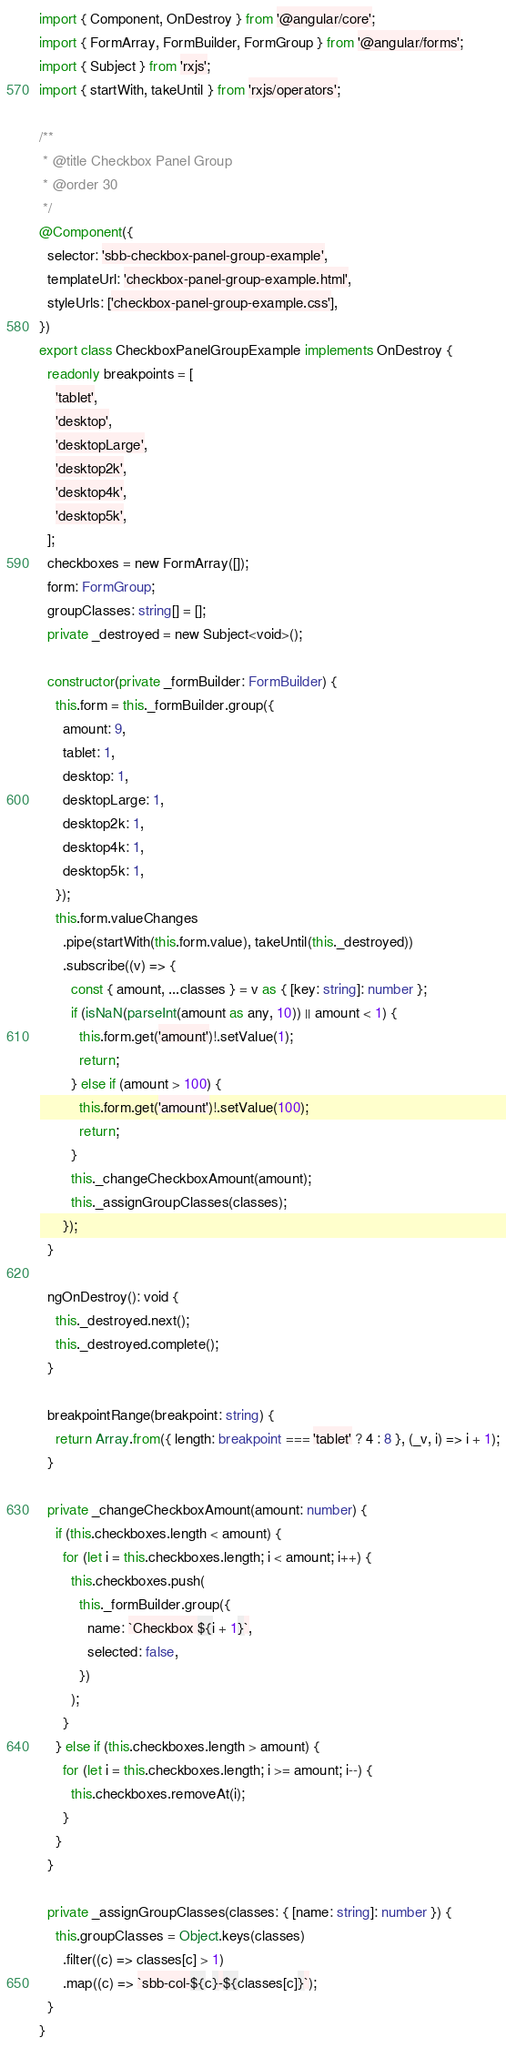<code> <loc_0><loc_0><loc_500><loc_500><_TypeScript_>import { Component, OnDestroy } from '@angular/core';
import { FormArray, FormBuilder, FormGroup } from '@angular/forms';
import { Subject } from 'rxjs';
import { startWith, takeUntil } from 'rxjs/operators';

/**
 * @title Checkbox Panel Group
 * @order 30
 */
@Component({
  selector: 'sbb-checkbox-panel-group-example',
  templateUrl: 'checkbox-panel-group-example.html',
  styleUrls: ['checkbox-panel-group-example.css'],
})
export class CheckboxPanelGroupExample implements OnDestroy {
  readonly breakpoints = [
    'tablet',
    'desktop',
    'desktopLarge',
    'desktop2k',
    'desktop4k',
    'desktop5k',
  ];
  checkboxes = new FormArray([]);
  form: FormGroup;
  groupClasses: string[] = [];
  private _destroyed = new Subject<void>();

  constructor(private _formBuilder: FormBuilder) {
    this.form = this._formBuilder.group({
      amount: 9,
      tablet: 1,
      desktop: 1,
      desktopLarge: 1,
      desktop2k: 1,
      desktop4k: 1,
      desktop5k: 1,
    });
    this.form.valueChanges
      .pipe(startWith(this.form.value), takeUntil(this._destroyed))
      .subscribe((v) => {
        const { amount, ...classes } = v as { [key: string]: number };
        if (isNaN(parseInt(amount as any, 10)) || amount < 1) {
          this.form.get('amount')!.setValue(1);
          return;
        } else if (amount > 100) {
          this.form.get('amount')!.setValue(100);
          return;
        }
        this._changeCheckboxAmount(amount);
        this._assignGroupClasses(classes);
      });
  }

  ngOnDestroy(): void {
    this._destroyed.next();
    this._destroyed.complete();
  }

  breakpointRange(breakpoint: string) {
    return Array.from({ length: breakpoint === 'tablet' ? 4 : 8 }, (_v, i) => i + 1);
  }

  private _changeCheckboxAmount(amount: number) {
    if (this.checkboxes.length < amount) {
      for (let i = this.checkboxes.length; i < amount; i++) {
        this.checkboxes.push(
          this._formBuilder.group({
            name: `Checkbox ${i + 1}`,
            selected: false,
          })
        );
      }
    } else if (this.checkboxes.length > amount) {
      for (let i = this.checkboxes.length; i >= amount; i--) {
        this.checkboxes.removeAt(i);
      }
    }
  }

  private _assignGroupClasses(classes: { [name: string]: number }) {
    this.groupClasses = Object.keys(classes)
      .filter((c) => classes[c] > 1)
      .map((c) => `sbb-col-${c}-${classes[c]}`);
  }
}
</code> 